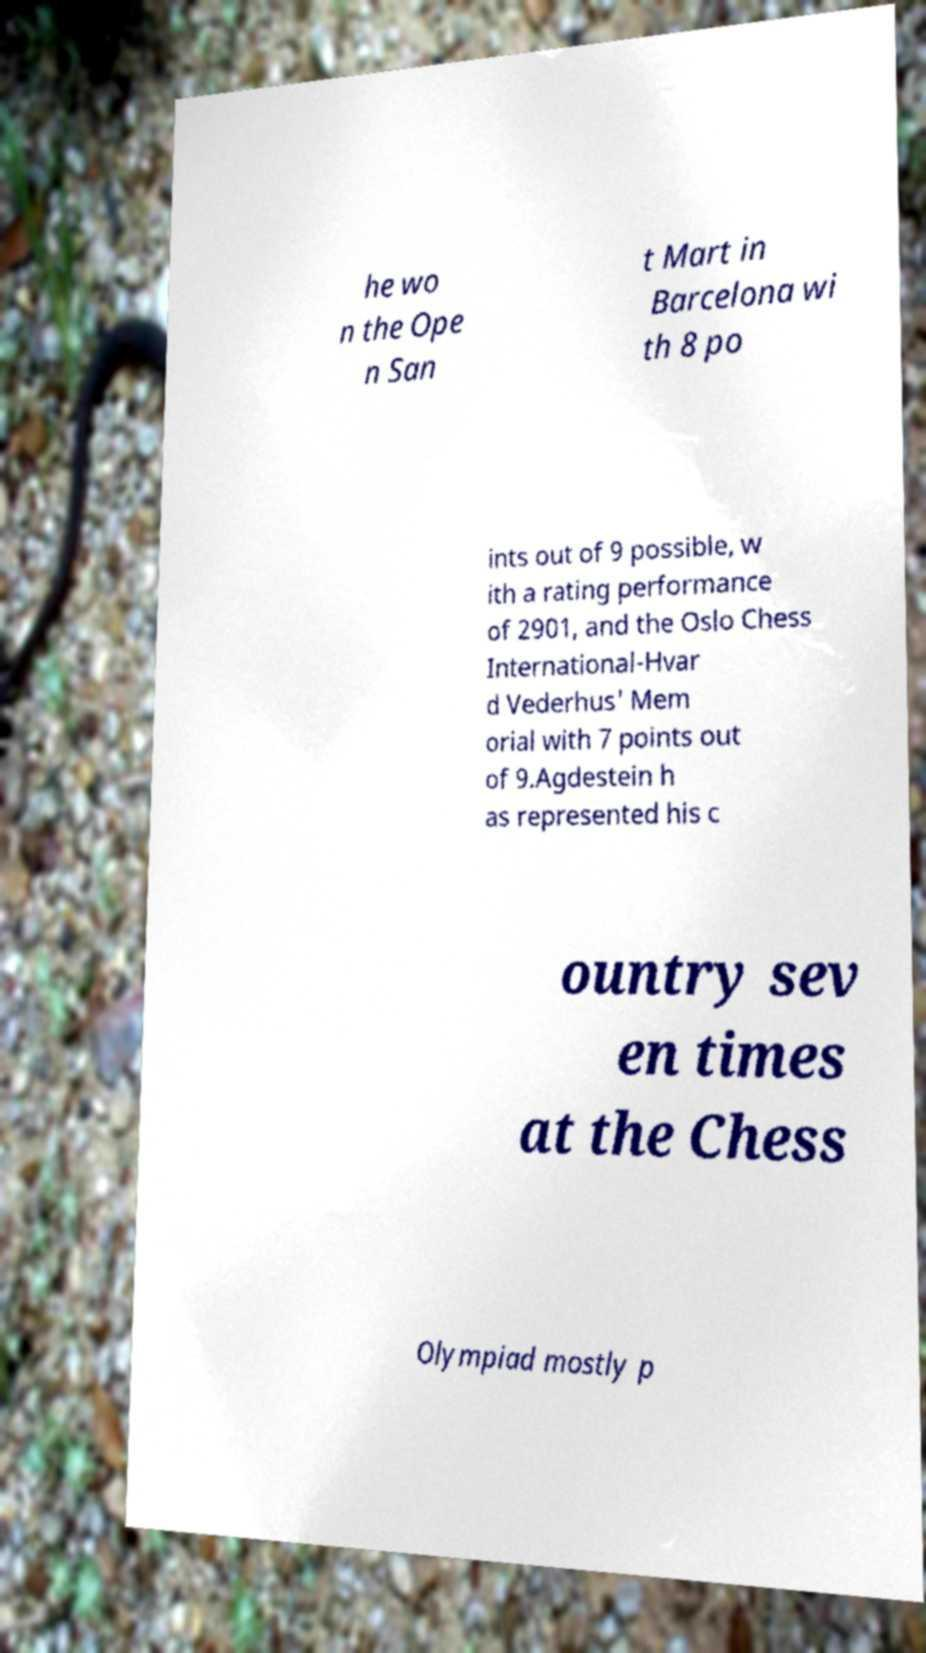What messages or text are displayed in this image? I need them in a readable, typed format. he wo n the Ope n San t Mart in Barcelona wi th 8 po ints out of 9 possible, w ith a rating performance of 2901, and the Oslo Chess International-Hvar d Vederhus' Mem orial with 7 points out of 9.Agdestein h as represented his c ountry sev en times at the Chess Olympiad mostly p 